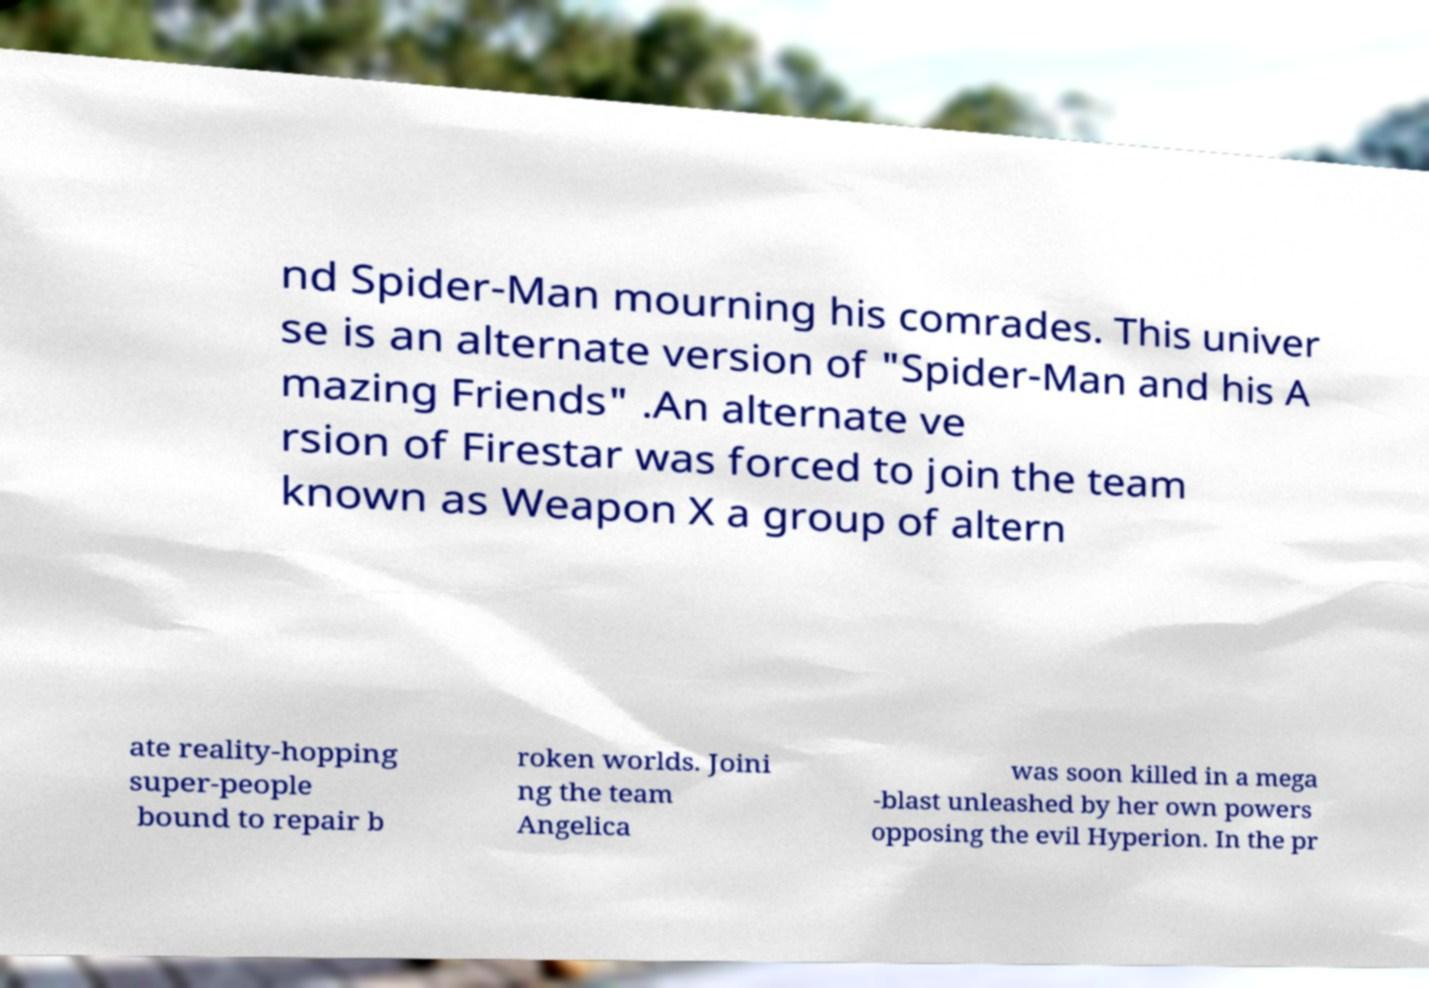Could you extract and type out the text from this image? nd Spider-Man mourning his comrades. This univer se is an alternate version of "Spider-Man and his A mazing Friends" .An alternate ve rsion of Firestar was forced to join the team known as Weapon X a group of altern ate reality-hopping super-people bound to repair b roken worlds. Joini ng the team Angelica was soon killed in a mega -blast unleashed by her own powers opposing the evil Hyperion. In the pr 